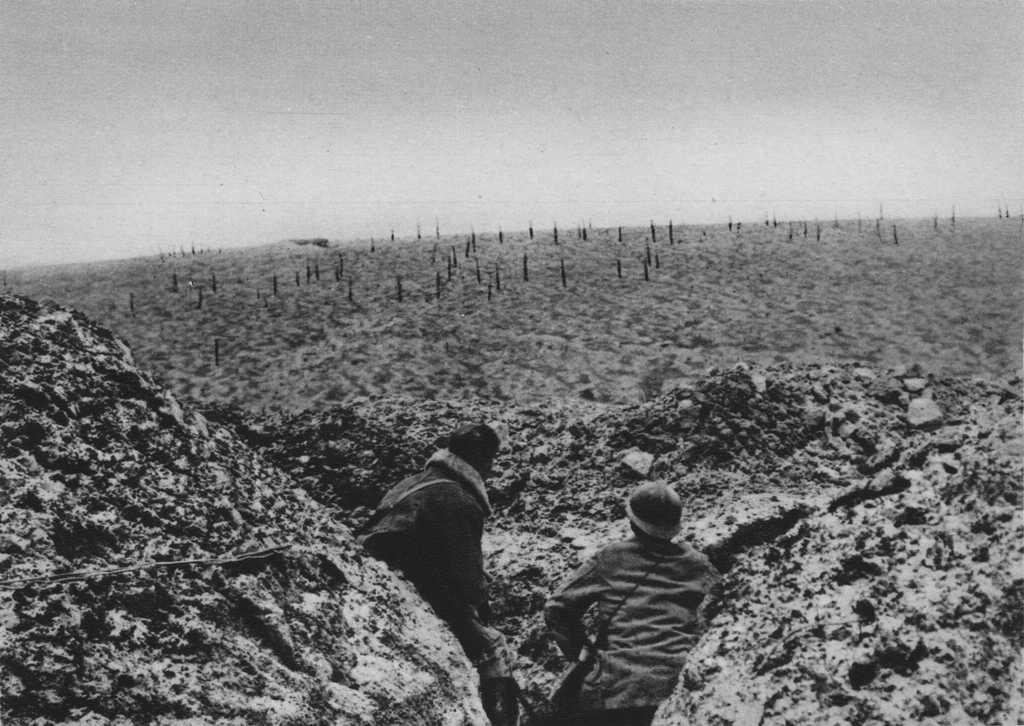What is the color scheme of the image? The image is black and white. How many people are in the image? There are two persons in the image. What can be seen in the middle of the image? There is a vast land in the middle of the image. What structures are present in the vast land? There are poles present in the vast land. What type of basin can be seen in the image? There is no basin present in the image. What is the person in the image doing with the hammer? There is no hammer present in the image, and therefore no such activity can be observed. 